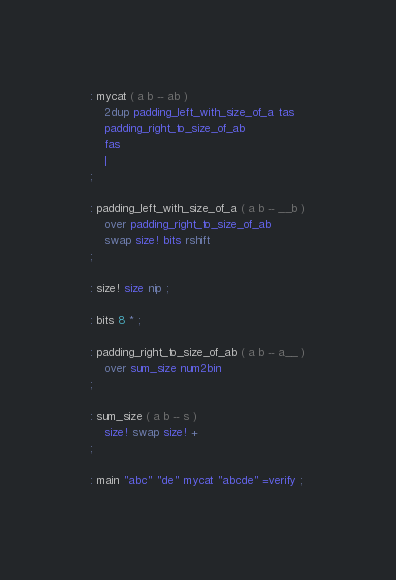Convert code to text. <code><loc_0><loc_0><loc_500><loc_500><_Forth_>: mycat ( a b -- ab )
    2dup padding_left_with_size_of_a tas
    padding_right_to_size_of_ab
    fas
    |
;

: padding_left_with_size_of_a ( a b -- __b )
    over padding_right_to_size_of_ab
    swap size! bits rshift
;

: size! size nip ;

: bits 8 * ;

: padding_right_to_size_of_ab ( a b -- a__ )
    over sum_size num2bin
;

: sum_size ( a b -- s )
    size! swap size! +
;

: main "abc" "de" mycat "abcde" =verify ;</code> 